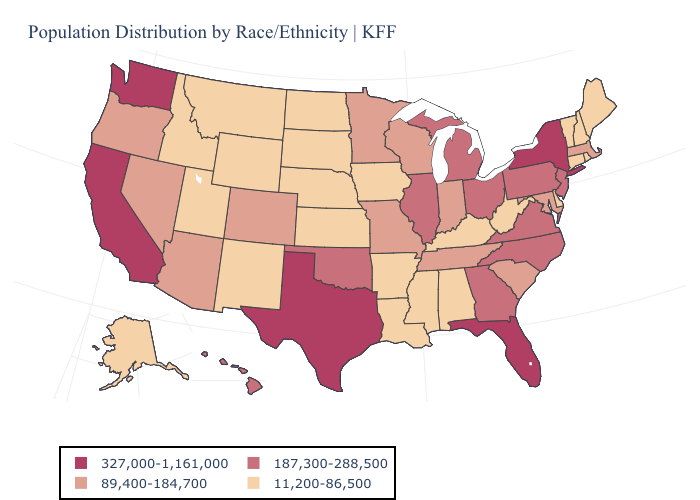Does the map have missing data?
Give a very brief answer. No. Is the legend a continuous bar?
Keep it brief. No. Name the states that have a value in the range 89,400-184,700?
Write a very short answer. Arizona, Colorado, Indiana, Maryland, Massachusetts, Minnesota, Missouri, Nevada, Oregon, South Carolina, Tennessee, Wisconsin. What is the value of Nebraska?
Quick response, please. 11,200-86,500. Name the states that have a value in the range 11,200-86,500?
Concise answer only. Alabama, Alaska, Arkansas, Connecticut, Delaware, Idaho, Iowa, Kansas, Kentucky, Louisiana, Maine, Mississippi, Montana, Nebraska, New Hampshire, New Mexico, North Dakota, Rhode Island, South Dakota, Utah, Vermont, West Virginia, Wyoming. Which states hav the highest value in the Northeast?
Quick response, please. New York. Does California have the highest value in the West?
Short answer required. Yes. What is the highest value in the West ?
Short answer required. 327,000-1,161,000. Name the states that have a value in the range 187,300-288,500?
Concise answer only. Georgia, Hawaii, Illinois, Michigan, New Jersey, North Carolina, Ohio, Oklahoma, Pennsylvania, Virginia. Name the states that have a value in the range 11,200-86,500?
Keep it brief. Alabama, Alaska, Arkansas, Connecticut, Delaware, Idaho, Iowa, Kansas, Kentucky, Louisiana, Maine, Mississippi, Montana, Nebraska, New Hampshire, New Mexico, North Dakota, Rhode Island, South Dakota, Utah, Vermont, West Virginia, Wyoming. What is the value of Utah?
Answer briefly. 11,200-86,500. Among the states that border South Carolina , which have the highest value?
Give a very brief answer. Georgia, North Carolina. What is the lowest value in states that border Nebraska?
Give a very brief answer. 11,200-86,500. Which states have the lowest value in the USA?
Keep it brief. Alabama, Alaska, Arkansas, Connecticut, Delaware, Idaho, Iowa, Kansas, Kentucky, Louisiana, Maine, Mississippi, Montana, Nebraska, New Hampshire, New Mexico, North Dakota, Rhode Island, South Dakota, Utah, Vermont, West Virginia, Wyoming. Does South Carolina have the highest value in the USA?
Give a very brief answer. No. 